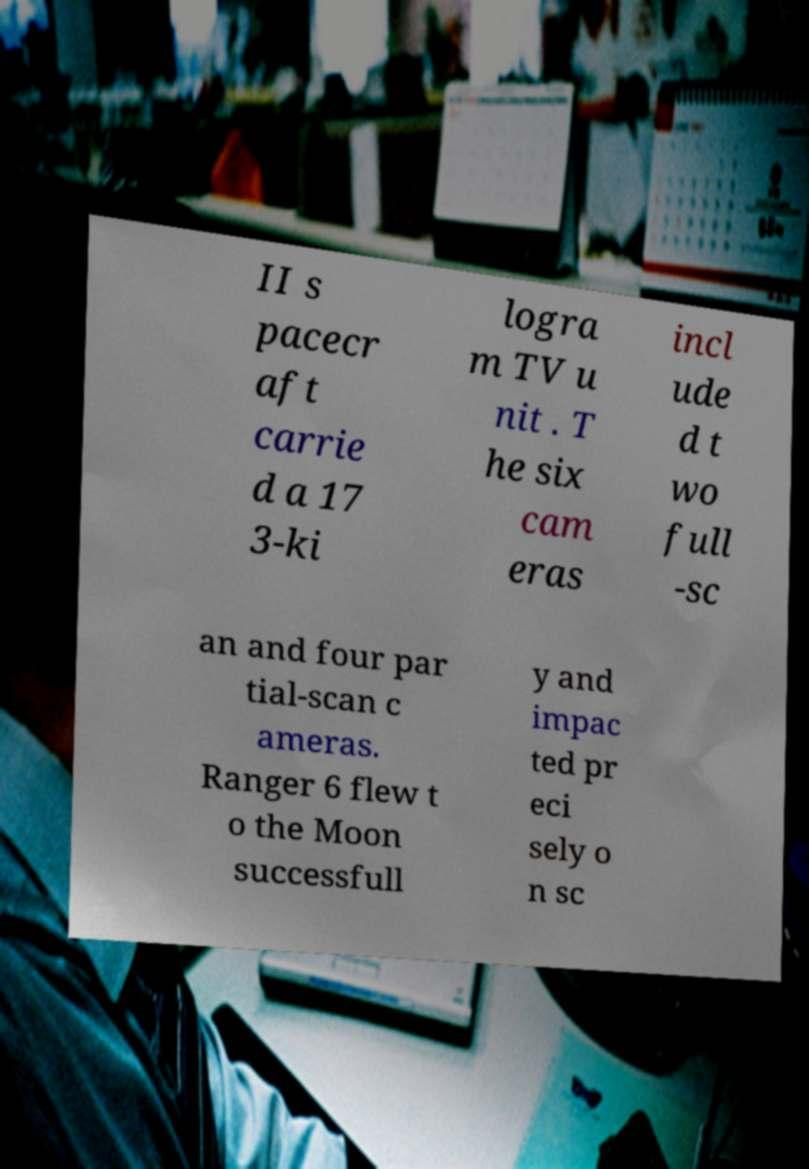Please identify and transcribe the text found in this image. II s pacecr aft carrie d a 17 3-ki logra m TV u nit . T he six cam eras incl ude d t wo full -sc an and four par tial-scan c ameras. Ranger 6 flew t o the Moon successfull y and impac ted pr eci sely o n sc 